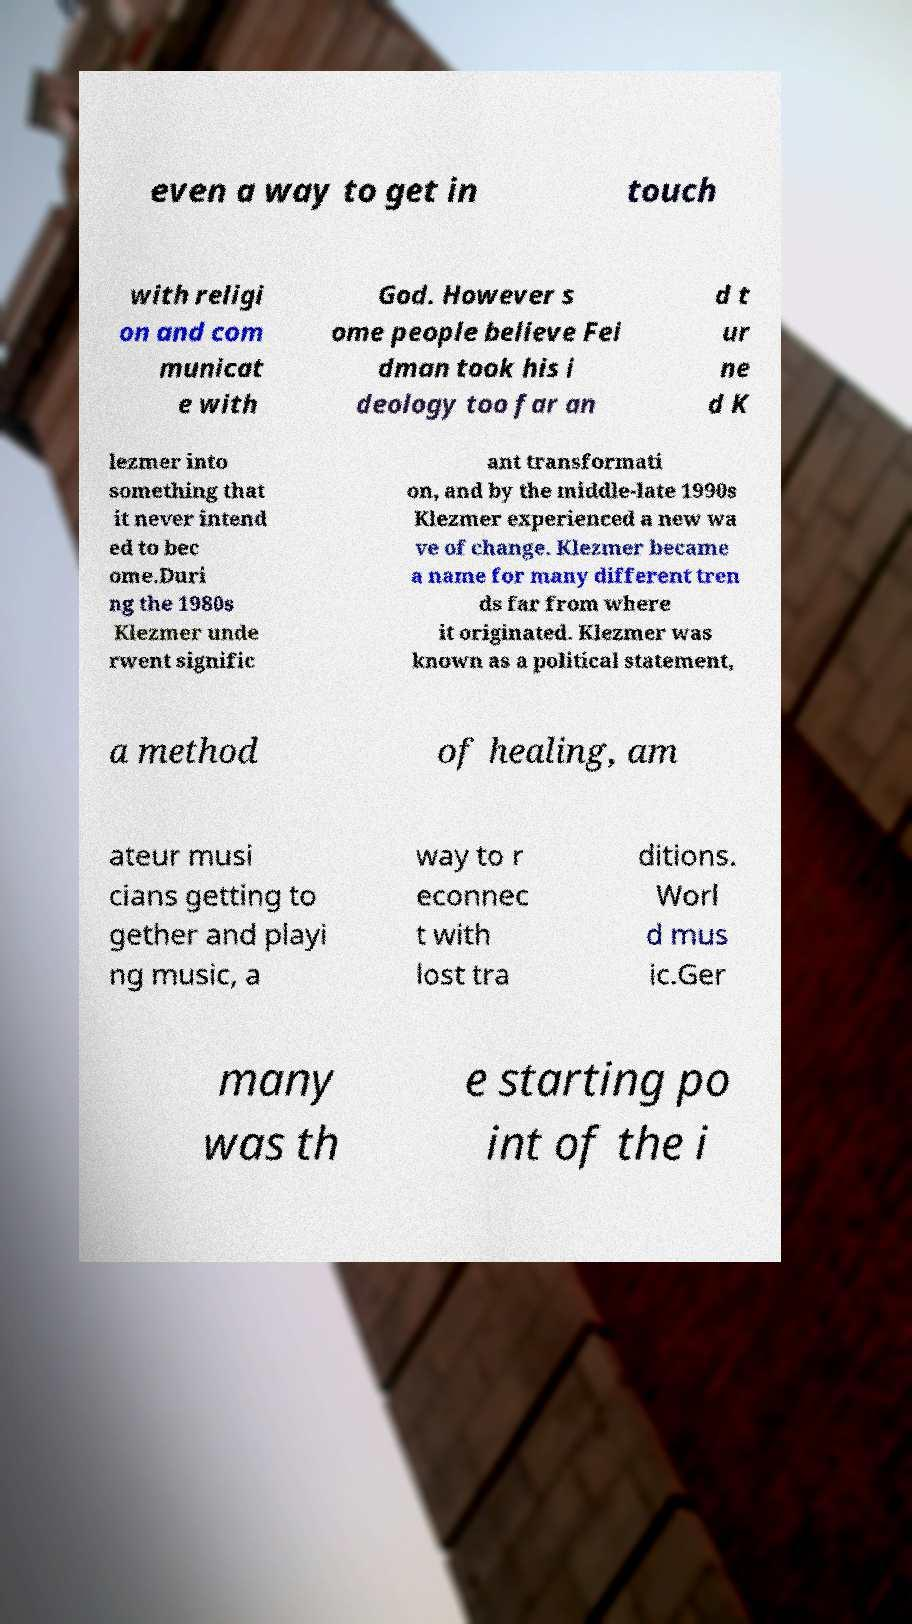There's text embedded in this image that I need extracted. Can you transcribe it verbatim? even a way to get in touch with religi on and com municat e with God. However s ome people believe Fei dman took his i deology too far an d t ur ne d K lezmer into something that it never intend ed to bec ome.Duri ng the 1980s Klezmer unde rwent signific ant transformati on, and by the middle-late 1990s Klezmer experienced a new wa ve of change. Klezmer became a name for many different tren ds far from where it originated. Klezmer was known as a political statement, a method of healing, am ateur musi cians getting to gether and playi ng music, a way to r econnec t with lost tra ditions. Worl d mus ic.Ger many was th e starting po int of the i 